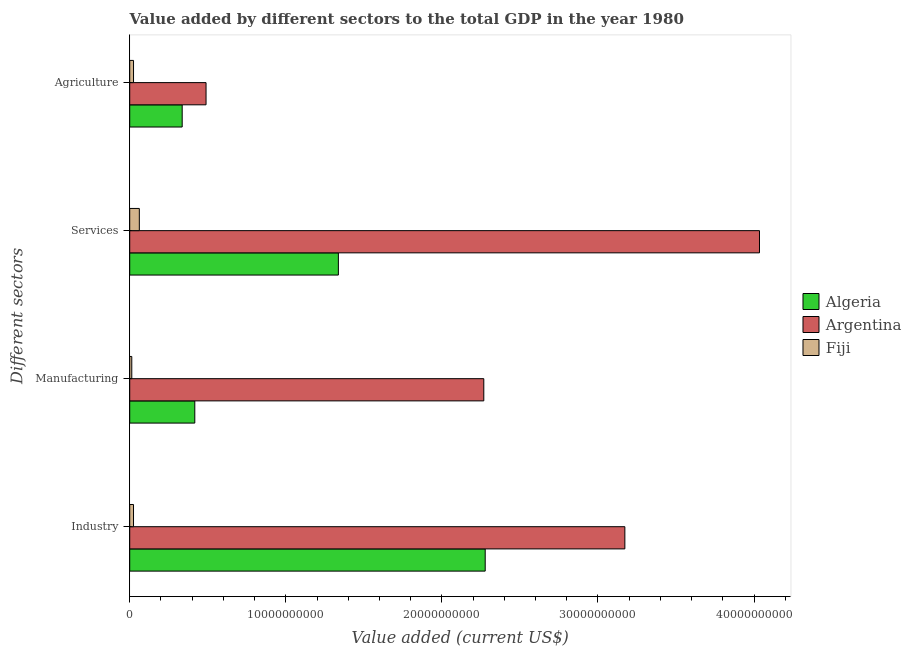How many different coloured bars are there?
Provide a short and direct response. 3. How many groups of bars are there?
Make the answer very short. 4. Are the number of bars on each tick of the Y-axis equal?
Offer a terse response. Yes. How many bars are there on the 2nd tick from the bottom?
Make the answer very short. 3. What is the label of the 4th group of bars from the top?
Provide a succinct answer. Industry. What is the value added by manufacturing sector in Algeria?
Offer a terse response. 4.17e+09. Across all countries, what is the maximum value added by agricultural sector?
Ensure brevity in your answer.  4.89e+09. Across all countries, what is the minimum value added by manufacturing sector?
Keep it short and to the point. 1.32e+08. In which country was the value added by agricultural sector minimum?
Your answer should be compact. Fiji. What is the total value added by services sector in the graph?
Provide a succinct answer. 5.43e+1. What is the difference between the value added by industrial sector in Algeria and that in Argentina?
Offer a terse response. -8.95e+09. What is the difference between the value added by services sector in Argentina and the value added by agricultural sector in Fiji?
Your response must be concise. 4.01e+1. What is the average value added by manufacturing sector per country?
Offer a very short reply. 9.00e+09. What is the difference between the value added by services sector and value added by industrial sector in Algeria?
Make the answer very short. -9.41e+09. In how many countries, is the value added by industrial sector greater than 38000000000 US$?
Ensure brevity in your answer.  0. What is the ratio of the value added by agricultural sector in Argentina to that in Fiji?
Your answer should be compact. 20.05. Is the value added by industrial sector in Algeria less than that in Argentina?
Your answer should be compact. Yes. Is the difference between the value added by services sector in Fiji and Argentina greater than the difference between the value added by industrial sector in Fiji and Argentina?
Your answer should be compact. No. What is the difference between the highest and the second highest value added by industrial sector?
Give a very brief answer. 8.95e+09. What is the difference between the highest and the lowest value added by agricultural sector?
Your answer should be compact. 4.65e+09. Is the sum of the value added by manufacturing sector in Fiji and Argentina greater than the maximum value added by services sector across all countries?
Provide a short and direct response. No. Is it the case that in every country, the sum of the value added by manufacturing sector and value added by agricultural sector is greater than the sum of value added by services sector and value added by industrial sector?
Your answer should be very brief. No. Is it the case that in every country, the sum of the value added by industrial sector and value added by manufacturing sector is greater than the value added by services sector?
Offer a terse response. No. How many bars are there?
Offer a very short reply. 12. Are all the bars in the graph horizontal?
Offer a very short reply. Yes. What is the difference between two consecutive major ticks on the X-axis?
Offer a terse response. 1.00e+1. Does the graph contain any zero values?
Give a very brief answer. No. How are the legend labels stacked?
Offer a terse response. Vertical. What is the title of the graph?
Provide a short and direct response. Value added by different sectors to the total GDP in the year 1980. Does "Bulgaria" appear as one of the legend labels in the graph?
Your answer should be compact. No. What is the label or title of the X-axis?
Your answer should be compact. Value added (current US$). What is the label or title of the Y-axis?
Your response must be concise. Different sectors. What is the Value added (current US$) in Algeria in Industry?
Your response must be concise. 2.28e+1. What is the Value added (current US$) of Argentina in Industry?
Keep it short and to the point. 3.17e+1. What is the Value added (current US$) in Fiji in Industry?
Ensure brevity in your answer.  2.42e+08. What is the Value added (current US$) of Algeria in Manufacturing?
Give a very brief answer. 4.17e+09. What is the Value added (current US$) of Argentina in Manufacturing?
Your answer should be compact. 2.27e+1. What is the Value added (current US$) in Fiji in Manufacturing?
Keep it short and to the point. 1.32e+08. What is the Value added (current US$) of Algeria in Services?
Your answer should be compact. 1.34e+1. What is the Value added (current US$) of Argentina in Services?
Your answer should be compact. 4.03e+1. What is the Value added (current US$) of Fiji in Services?
Your answer should be very brief. 6.15e+08. What is the Value added (current US$) in Algeria in Agriculture?
Your answer should be very brief. 3.36e+09. What is the Value added (current US$) in Argentina in Agriculture?
Your answer should be very brief. 4.89e+09. What is the Value added (current US$) of Fiji in Agriculture?
Offer a terse response. 2.44e+08. Across all Different sectors, what is the maximum Value added (current US$) in Algeria?
Your answer should be very brief. 2.28e+1. Across all Different sectors, what is the maximum Value added (current US$) of Argentina?
Your answer should be compact. 4.03e+1. Across all Different sectors, what is the maximum Value added (current US$) of Fiji?
Your answer should be very brief. 6.15e+08. Across all Different sectors, what is the minimum Value added (current US$) in Algeria?
Provide a short and direct response. 3.36e+09. Across all Different sectors, what is the minimum Value added (current US$) of Argentina?
Your answer should be very brief. 4.89e+09. Across all Different sectors, what is the minimum Value added (current US$) of Fiji?
Ensure brevity in your answer.  1.32e+08. What is the total Value added (current US$) in Algeria in the graph?
Provide a short and direct response. 4.37e+1. What is the total Value added (current US$) in Argentina in the graph?
Your answer should be compact. 9.96e+1. What is the total Value added (current US$) of Fiji in the graph?
Your answer should be compact. 1.23e+09. What is the difference between the Value added (current US$) of Algeria in Industry and that in Manufacturing?
Offer a very short reply. 1.86e+1. What is the difference between the Value added (current US$) of Argentina in Industry and that in Manufacturing?
Ensure brevity in your answer.  9.04e+09. What is the difference between the Value added (current US$) of Fiji in Industry and that in Manufacturing?
Provide a succinct answer. 1.11e+08. What is the difference between the Value added (current US$) in Algeria in Industry and that in Services?
Provide a succinct answer. 9.41e+09. What is the difference between the Value added (current US$) in Argentina in Industry and that in Services?
Your response must be concise. -8.63e+09. What is the difference between the Value added (current US$) in Fiji in Industry and that in Services?
Your answer should be very brief. -3.73e+08. What is the difference between the Value added (current US$) in Algeria in Industry and that in Agriculture?
Ensure brevity in your answer.  1.94e+1. What is the difference between the Value added (current US$) in Argentina in Industry and that in Agriculture?
Your response must be concise. 2.68e+1. What is the difference between the Value added (current US$) of Fiji in Industry and that in Agriculture?
Your answer should be very brief. -1.47e+06. What is the difference between the Value added (current US$) of Algeria in Manufacturing and that in Services?
Provide a short and direct response. -9.20e+09. What is the difference between the Value added (current US$) in Argentina in Manufacturing and that in Services?
Your response must be concise. -1.77e+1. What is the difference between the Value added (current US$) in Fiji in Manufacturing and that in Services?
Your response must be concise. -4.84e+08. What is the difference between the Value added (current US$) of Algeria in Manufacturing and that in Agriculture?
Provide a short and direct response. 8.08e+08. What is the difference between the Value added (current US$) of Argentina in Manufacturing and that in Agriculture?
Ensure brevity in your answer.  1.78e+1. What is the difference between the Value added (current US$) in Fiji in Manufacturing and that in Agriculture?
Provide a succinct answer. -1.12e+08. What is the difference between the Value added (current US$) in Algeria in Services and that in Agriculture?
Provide a succinct answer. 1.00e+1. What is the difference between the Value added (current US$) of Argentina in Services and that in Agriculture?
Offer a terse response. 3.55e+1. What is the difference between the Value added (current US$) in Fiji in Services and that in Agriculture?
Give a very brief answer. 3.71e+08. What is the difference between the Value added (current US$) in Algeria in Industry and the Value added (current US$) in Argentina in Manufacturing?
Offer a terse response. 8.99e+07. What is the difference between the Value added (current US$) of Algeria in Industry and the Value added (current US$) of Fiji in Manufacturing?
Your response must be concise. 2.26e+1. What is the difference between the Value added (current US$) in Argentina in Industry and the Value added (current US$) in Fiji in Manufacturing?
Your response must be concise. 3.16e+1. What is the difference between the Value added (current US$) of Algeria in Industry and the Value added (current US$) of Argentina in Services?
Offer a terse response. -1.76e+1. What is the difference between the Value added (current US$) of Algeria in Industry and the Value added (current US$) of Fiji in Services?
Provide a short and direct response. 2.22e+1. What is the difference between the Value added (current US$) in Argentina in Industry and the Value added (current US$) in Fiji in Services?
Make the answer very short. 3.11e+1. What is the difference between the Value added (current US$) of Algeria in Industry and the Value added (current US$) of Argentina in Agriculture?
Keep it short and to the point. 1.79e+1. What is the difference between the Value added (current US$) of Algeria in Industry and the Value added (current US$) of Fiji in Agriculture?
Provide a short and direct response. 2.25e+1. What is the difference between the Value added (current US$) in Argentina in Industry and the Value added (current US$) in Fiji in Agriculture?
Provide a short and direct response. 3.15e+1. What is the difference between the Value added (current US$) in Algeria in Manufacturing and the Value added (current US$) in Argentina in Services?
Provide a succinct answer. -3.62e+1. What is the difference between the Value added (current US$) in Algeria in Manufacturing and the Value added (current US$) in Fiji in Services?
Ensure brevity in your answer.  3.55e+09. What is the difference between the Value added (current US$) of Argentina in Manufacturing and the Value added (current US$) of Fiji in Services?
Offer a terse response. 2.21e+1. What is the difference between the Value added (current US$) of Algeria in Manufacturing and the Value added (current US$) of Argentina in Agriculture?
Your response must be concise. -7.20e+08. What is the difference between the Value added (current US$) in Algeria in Manufacturing and the Value added (current US$) in Fiji in Agriculture?
Give a very brief answer. 3.93e+09. What is the difference between the Value added (current US$) in Argentina in Manufacturing and the Value added (current US$) in Fiji in Agriculture?
Make the answer very short. 2.24e+1. What is the difference between the Value added (current US$) of Algeria in Services and the Value added (current US$) of Argentina in Agriculture?
Offer a very short reply. 8.48e+09. What is the difference between the Value added (current US$) in Algeria in Services and the Value added (current US$) in Fiji in Agriculture?
Offer a terse response. 1.31e+1. What is the difference between the Value added (current US$) in Argentina in Services and the Value added (current US$) in Fiji in Agriculture?
Make the answer very short. 4.01e+1. What is the average Value added (current US$) of Algeria per Different sectors?
Provide a short and direct response. 1.09e+1. What is the average Value added (current US$) of Argentina per Different sectors?
Give a very brief answer. 2.49e+1. What is the average Value added (current US$) of Fiji per Different sectors?
Your answer should be very brief. 3.08e+08. What is the difference between the Value added (current US$) in Algeria and Value added (current US$) in Argentina in Industry?
Your response must be concise. -8.95e+09. What is the difference between the Value added (current US$) of Algeria and Value added (current US$) of Fiji in Industry?
Your answer should be compact. 2.25e+1. What is the difference between the Value added (current US$) of Argentina and Value added (current US$) of Fiji in Industry?
Provide a succinct answer. 3.15e+1. What is the difference between the Value added (current US$) in Algeria and Value added (current US$) in Argentina in Manufacturing?
Keep it short and to the point. -1.85e+1. What is the difference between the Value added (current US$) of Algeria and Value added (current US$) of Fiji in Manufacturing?
Offer a very short reply. 4.04e+09. What is the difference between the Value added (current US$) of Argentina and Value added (current US$) of Fiji in Manufacturing?
Offer a very short reply. 2.26e+1. What is the difference between the Value added (current US$) in Algeria and Value added (current US$) in Argentina in Services?
Offer a terse response. -2.70e+1. What is the difference between the Value added (current US$) of Algeria and Value added (current US$) of Fiji in Services?
Provide a succinct answer. 1.28e+1. What is the difference between the Value added (current US$) in Argentina and Value added (current US$) in Fiji in Services?
Offer a very short reply. 3.97e+1. What is the difference between the Value added (current US$) in Algeria and Value added (current US$) in Argentina in Agriculture?
Give a very brief answer. -1.53e+09. What is the difference between the Value added (current US$) in Algeria and Value added (current US$) in Fiji in Agriculture?
Offer a terse response. 3.12e+09. What is the difference between the Value added (current US$) of Argentina and Value added (current US$) of Fiji in Agriculture?
Your response must be concise. 4.65e+09. What is the ratio of the Value added (current US$) in Algeria in Industry to that in Manufacturing?
Your response must be concise. 5.46. What is the ratio of the Value added (current US$) in Argentina in Industry to that in Manufacturing?
Give a very brief answer. 1.4. What is the ratio of the Value added (current US$) in Fiji in Industry to that in Manufacturing?
Offer a very short reply. 1.84. What is the ratio of the Value added (current US$) in Algeria in Industry to that in Services?
Your answer should be compact. 1.7. What is the ratio of the Value added (current US$) in Argentina in Industry to that in Services?
Provide a short and direct response. 0.79. What is the ratio of the Value added (current US$) of Fiji in Industry to that in Services?
Keep it short and to the point. 0.39. What is the ratio of the Value added (current US$) in Algeria in Industry to that in Agriculture?
Keep it short and to the point. 6.78. What is the ratio of the Value added (current US$) of Argentina in Industry to that in Agriculture?
Provide a short and direct response. 6.49. What is the ratio of the Value added (current US$) in Fiji in Industry to that in Agriculture?
Your answer should be very brief. 0.99. What is the ratio of the Value added (current US$) in Algeria in Manufacturing to that in Services?
Offer a very short reply. 0.31. What is the ratio of the Value added (current US$) in Argentina in Manufacturing to that in Services?
Your answer should be compact. 0.56. What is the ratio of the Value added (current US$) of Fiji in Manufacturing to that in Services?
Offer a very short reply. 0.21. What is the ratio of the Value added (current US$) in Algeria in Manufacturing to that in Agriculture?
Provide a succinct answer. 1.24. What is the ratio of the Value added (current US$) of Argentina in Manufacturing to that in Agriculture?
Provide a short and direct response. 4.64. What is the ratio of the Value added (current US$) of Fiji in Manufacturing to that in Agriculture?
Ensure brevity in your answer.  0.54. What is the ratio of the Value added (current US$) in Algeria in Services to that in Agriculture?
Your response must be concise. 3.98. What is the ratio of the Value added (current US$) in Argentina in Services to that in Agriculture?
Provide a succinct answer. 8.25. What is the ratio of the Value added (current US$) of Fiji in Services to that in Agriculture?
Offer a terse response. 2.52. What is the difference between the highest and the second highest Value added (current US$) in Algeria?
Keep it short and to the point. 9.41e+09. What is the difference between the highest and the second highest Value added (current US$) of Argentina?
Give a very brief answer. 8.63e+09. What is the difference between the highest and the second highest Value added (current US$) of Fiji?
Keep it short and to the point. 3.71e+08. What is the difference between the highest and the lowest Value added (current US$) in Algeria?
Provide a succinct answer. 1.94e+1. What is the difference between the highest and the lowest Value added (current US$) of Argentina?
Your response must be concise. 3.55e+1. What is the difference between the highest and the lowest Value added (current US$) in Fiji?
Your response must be concise. 4.84e+08. 